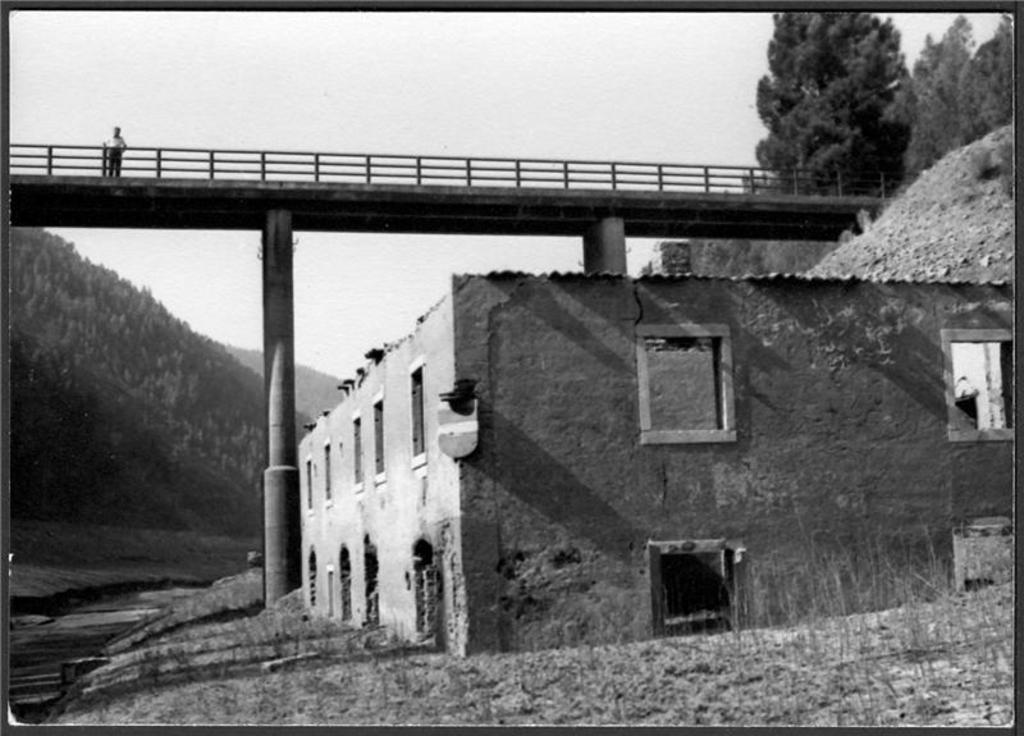Describe this image in one or two sentences. This is the picture of a place where we have a building to which there are some windows and also we can see a person on the bridge which has a fencing and around there are some mountains, trees and plants. 